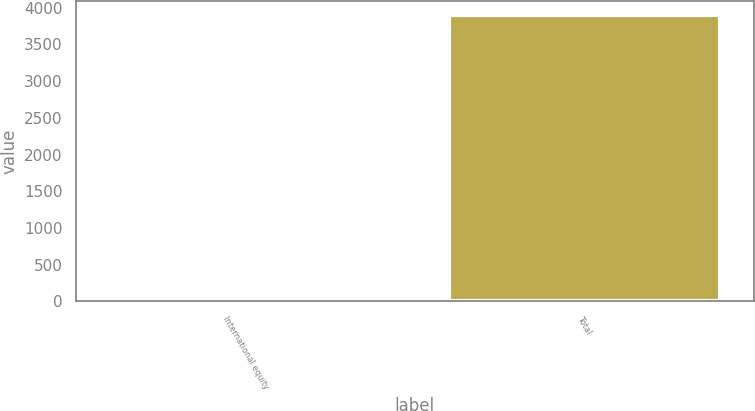Convert chart to OTSL. <chart><loc_0><loc_0><loc_500><loc_500><bar_chart><fcel>International equity<fcel>Total<nl><fcel>11<fcel>3902<nl></chart> 